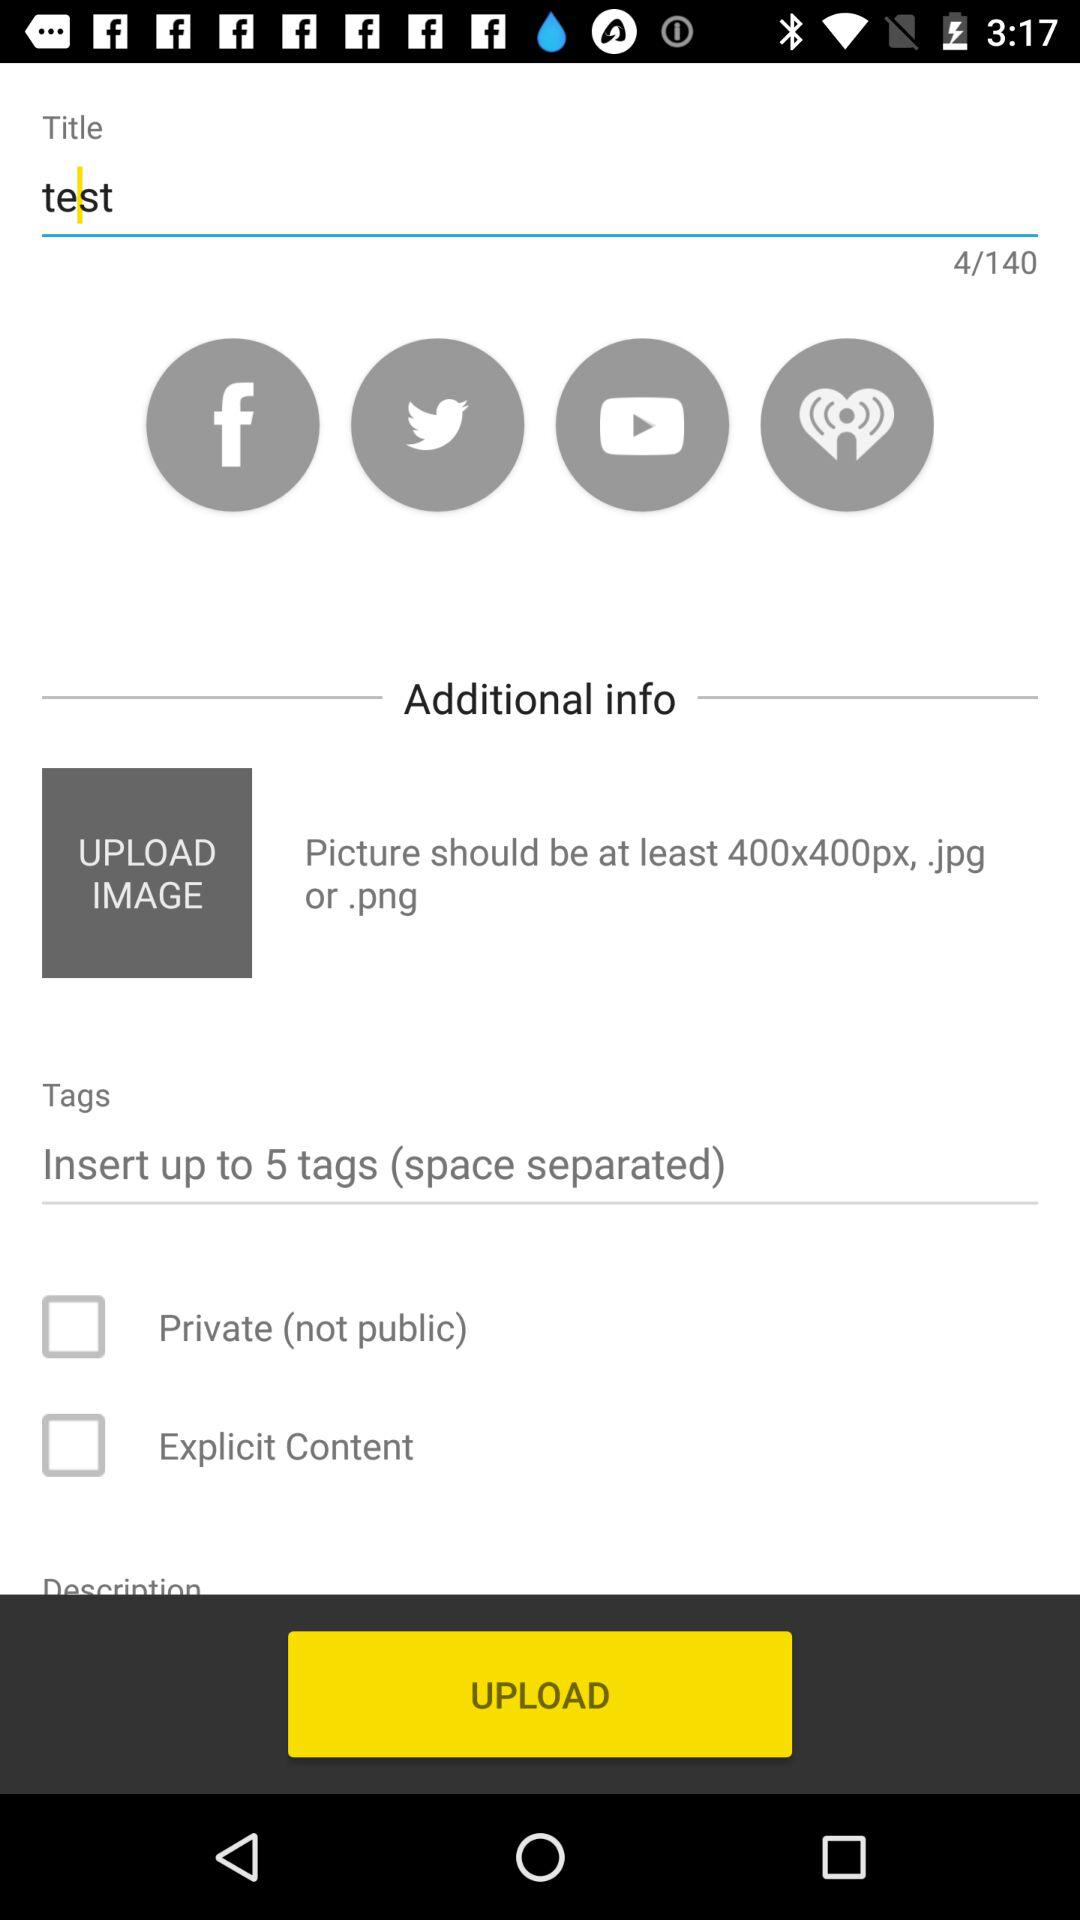What is the status of "Private"? The status of "Private" is "off". 